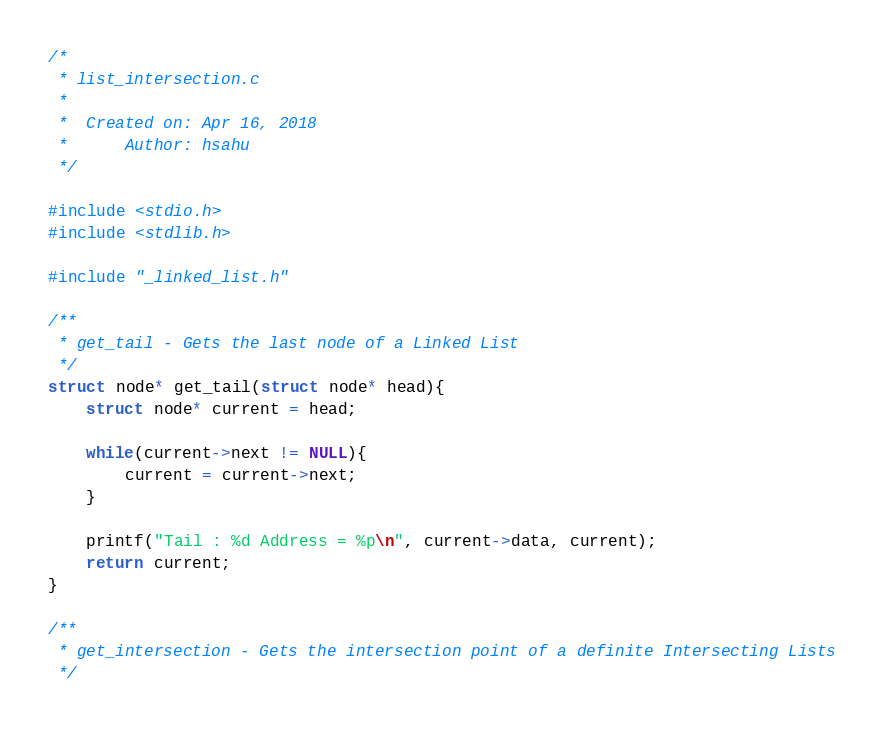Convert code to text. <code><loc_0><loc_0><loc_500><loc_500><_C_>/*
 * list_intersection.c
 *
 *  Created on: Apr 16, 2018
 *      Author: hsahu
 */

#include <stdio.h>
#include <stdlib.h>

#include "_linked_list.h"

/**
 * get_tail - Gets the last node of a Linked List
 */
struct node* get_tail(struct node* head){
	struct node* current = head;

	while(current->next != NULL){
		current = current->next;
	}

	printf("Tail : %d Address = %p\n", current->data, current);
	return current;
}

/**
 * get_intersection - Gets the intersection point of a definite Intersecting Lists
 */</code> 